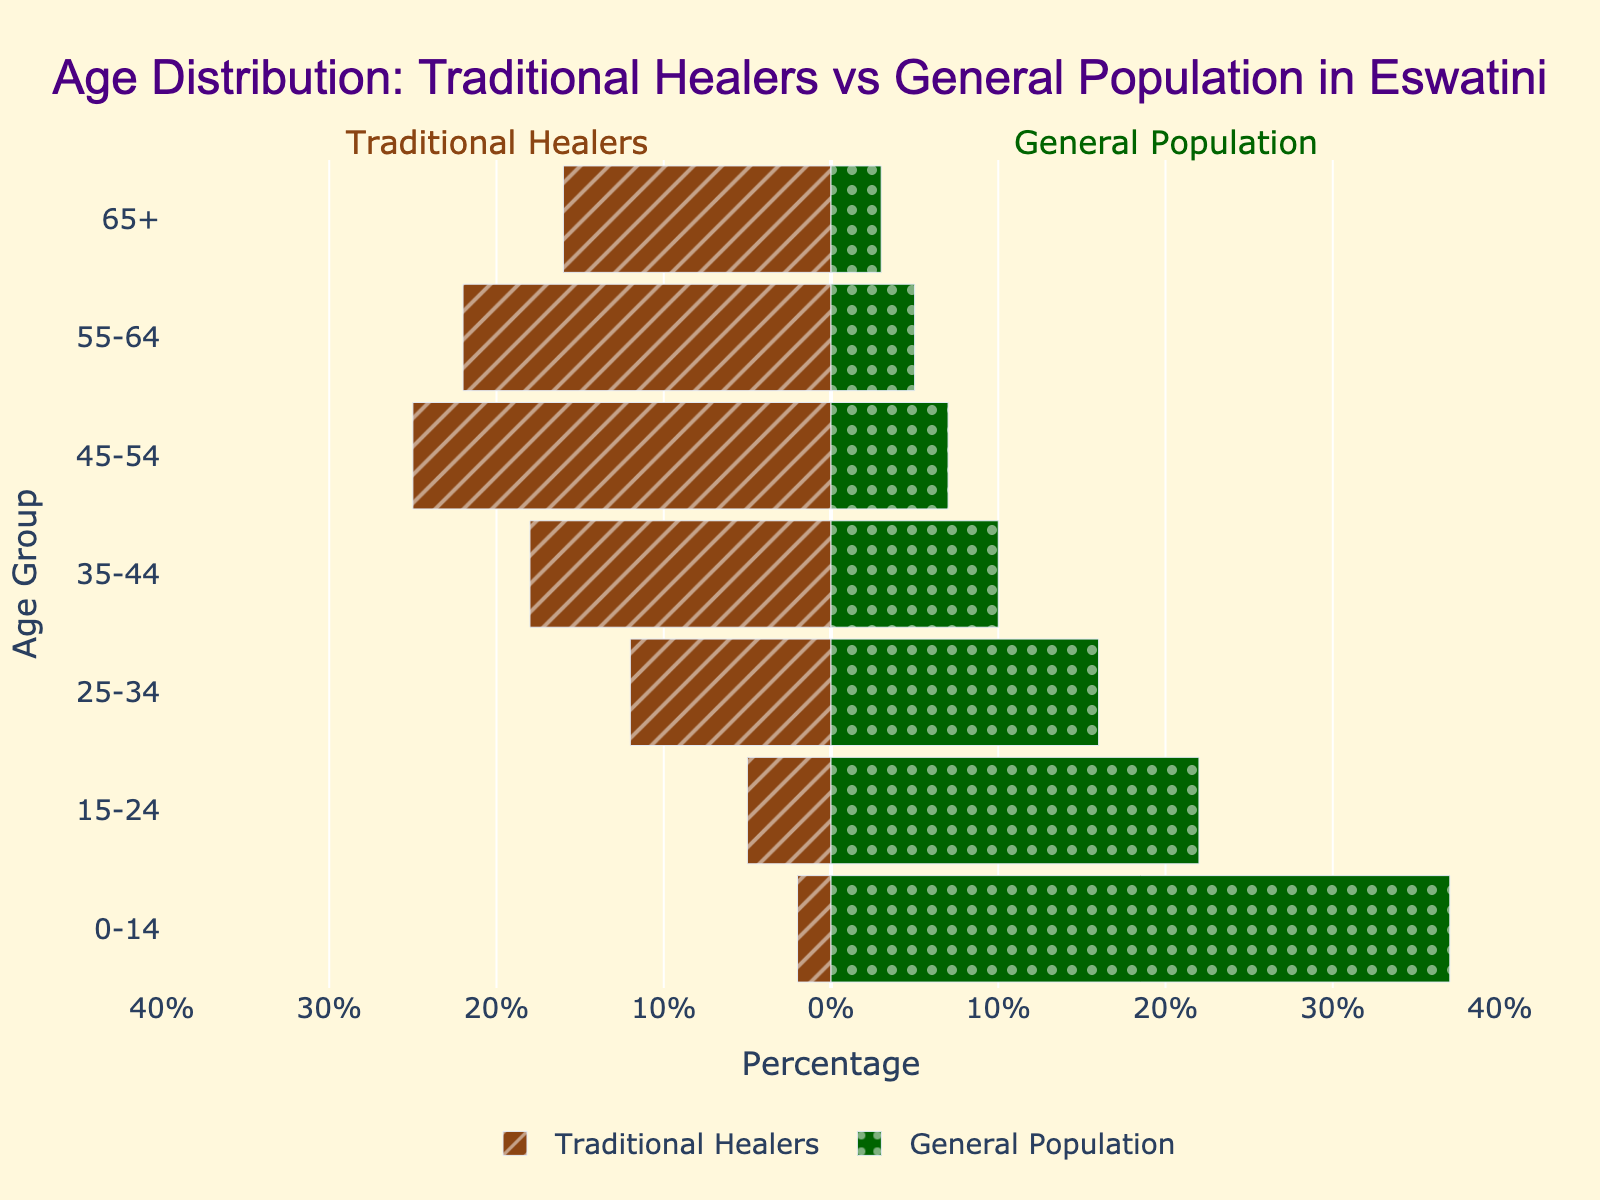What is the title of the figure? The title can be found at the top of the figure.
Answer: Age Distribution: Traditional Healers vs General Population in Eswatini What color represents traditional healers in the figure? The traditional healers' bars are depicted with a specific color.
Answer: Brown What is the age group with the lowest percentage of traditional healers? Look for the bar with the shortest length in the 'Traditional Healers' section.
Answer: 0-14 What is the total percentage of traditional healers aged 45 and above? The percentages for 45-54, 55-64, and 65+ are 25%, 22%, and 16% respectively. Adding them gives 25 + 22 + 16.
Answer: 63% What is the difference in percentage between the age groups 35-44 and 55-64 for traditional healers? The percentage of traditional healers in 35-44 is 18%, and in 55-64 is 22%. Subtract 18 from 22.
Answer: 4% Which age group has a higher percentage in the general population compared to traditional healers? Compare the percentage values between both groups for each age group.
Answer: 0-14, 15-24 Which age group shows the widest gap in percentage between traditional healers and the general population? Calculate the difference for each age group and find the maximum value.
Answer: 0-14 How is the data divided in the Population Pyramid? Data is divided by age groups, represented horizontally, with traditional healers' data on the left side (negative values) and general population data on the right side.
Answer: By age groups, horizontally What age group has a similar percentage between traditional healers and the general population? Identify age groups where the two bars have similar lengths.
Answer: 25-34 